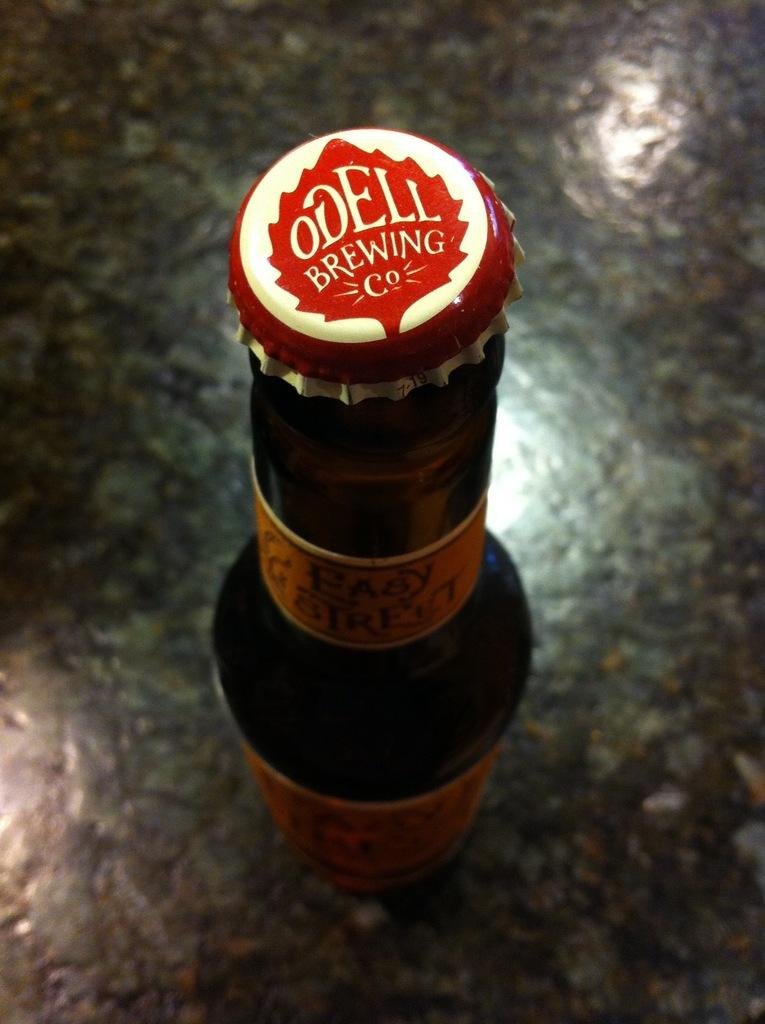<image>
Give a short and clear explanation of the subsequent image. A bottle of beer with Odell Brewing co written on the cap 